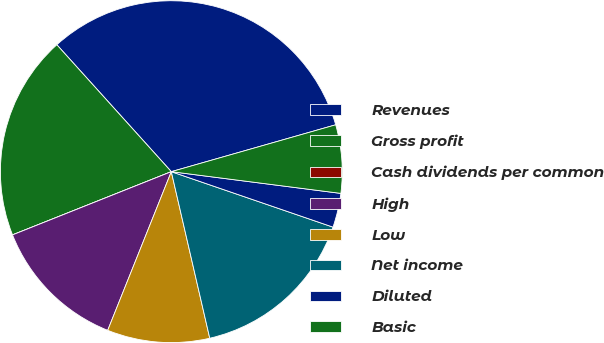Convert chart. <chart><loc_0><loc_0><loc_500><loc_500><pie_chart><fcel>Revenues<fcel>Gross profit<fcel>Cash dividends per common<fcel>High<fcel>Low<fcel>Net income<fcel>Diluted<fcel>Basic<nl><fcel>32.26%<fcel>19.35%<fcel>0.0%<fcel>12.9%<fcel>9.68%<fcel>16.13%<fcel>3.23%<fcel>6.45%<nl></chart> 